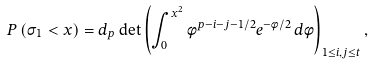Convert formula to latex. <formula><loc_0><loc_0><loc_500><loc_500>P \left ( \sigma _ { 1 } < x \right ) = d _ { p } \det \left ( \int _ { 0 } ^ { x ^ { 2 } } \phi ^ { p - i - j - 1 / 2 } e ^ { - \phi / 2 } \, d \phi \right ) _ { 1 \leq i , j \leq t } ,</formula> 